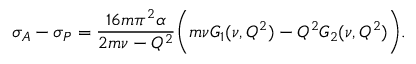Convert formula to latex. <formula><loc_0><loc_0><loc_500><loc_500>\sigma _ { A } - \sigma _ { P } = { \frac { 1 6 m \pi ^ { 2 } \alpha } { 2 m \nu - Q ^ { 2 } } } \left ( m \nu G _ { 1 } ( \nu , Q ^ { 2 } ) - Q ^ { 2 } G _ { 2 } ( \nu , Q ^ { 2 } ) \right ) .</formula> 